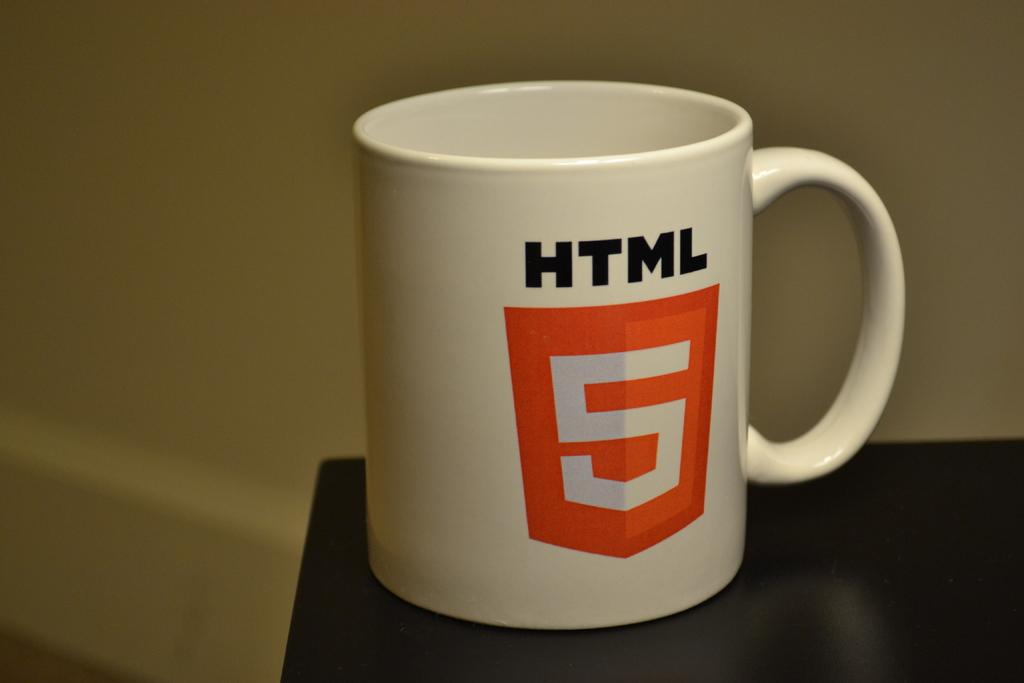<image>
Share a concise interpretation of the image provided. A white cup with black font reading HTML and a orange shield with a number 5. 